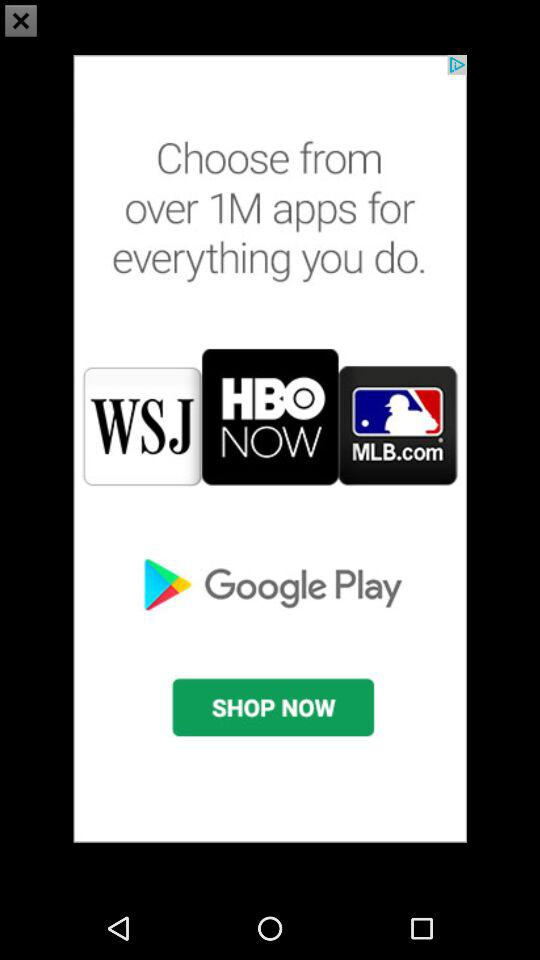How many apps are available for download?
Answer the question using a single word or phrase. 1M 